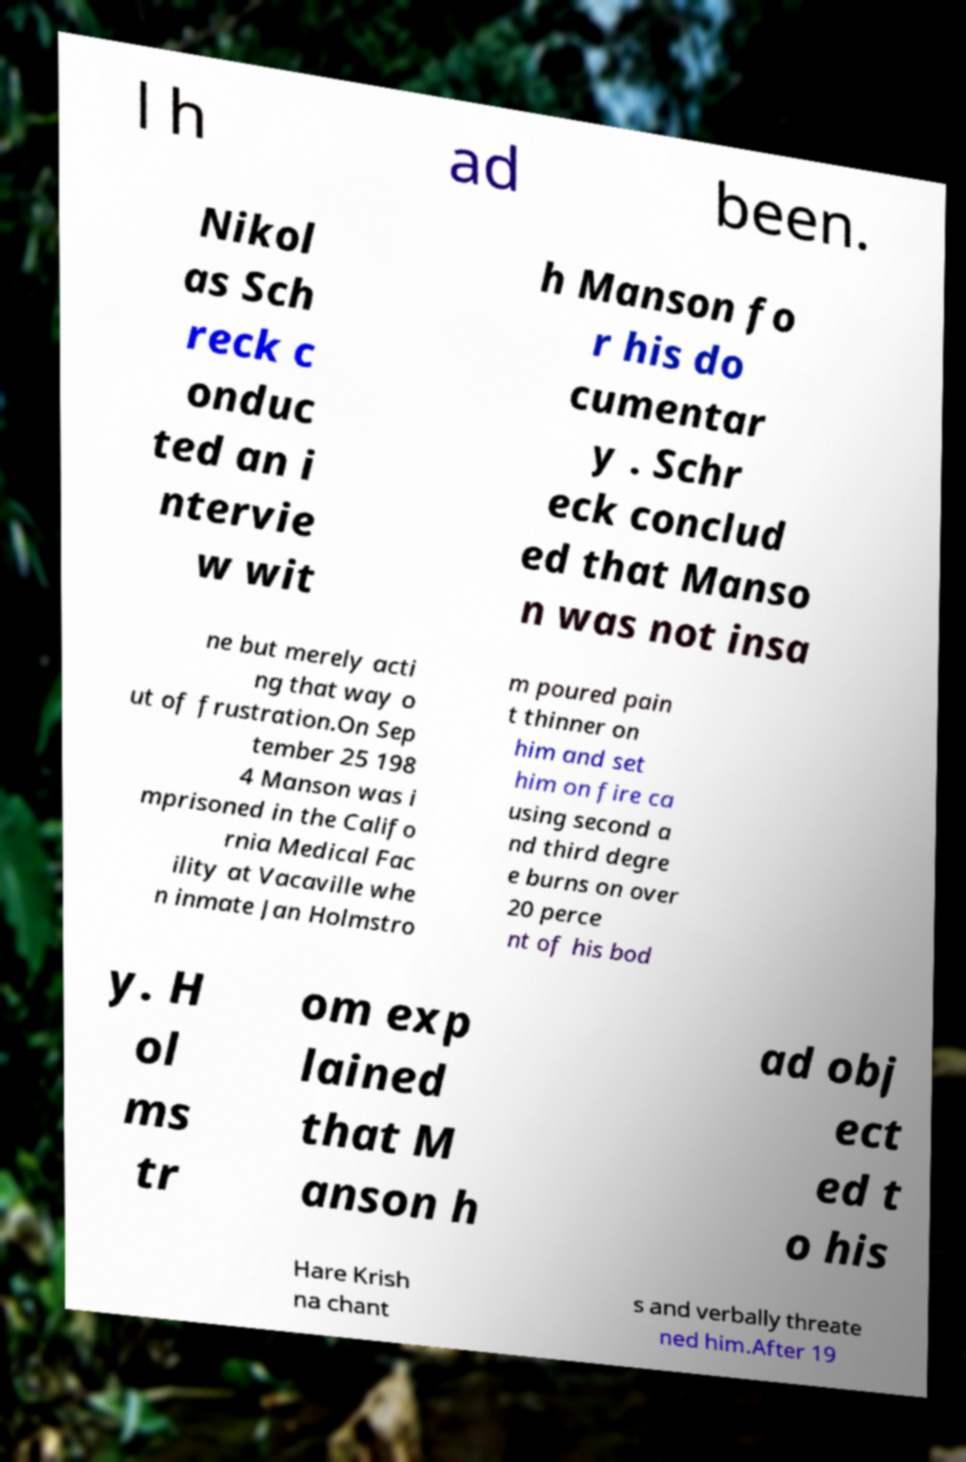There's text embedded in this image that I need extracted. Can you transcribe it verbatim? l h ad been. Nikol as Sch reck c onduc ted an i ntervie w wit h Manson fo r his do cumentar y . Schr eck conclud ed that Manso n was not insa ne but merely acti ng that way o ut of frustration.On Sep tember 25 198 4 Manson was i mprisoned in the Califo rnia Medical Fac ility at Vacaville whe n inmate Jan Holmstro m poured pain t thinner on him and set him on fire ca using second a nd third degre e burns on over 20 perce nt of his bod y. H ol ms tr om exp lained that M anson h ad obj ect ed t o his Hare Krish na chant s and verbally threate ned him.After 19 